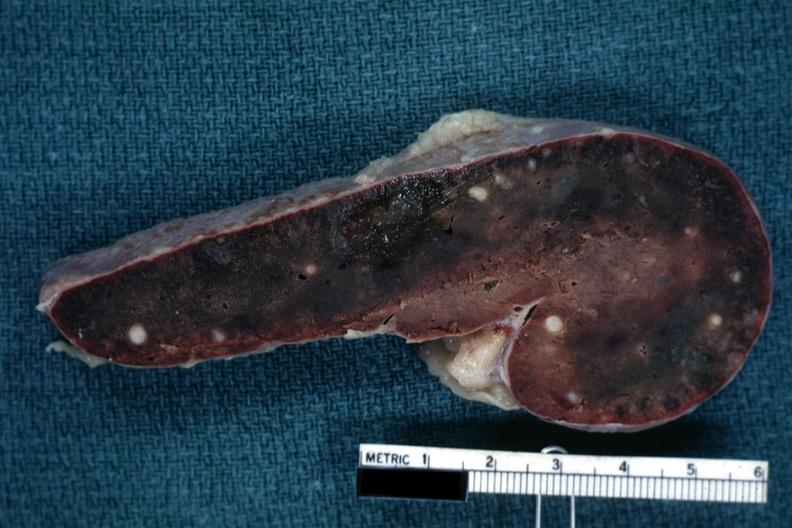how is fixed tissue cut surface parenchyma with obvious granulomas?
Answer the question using a single word or phrase. Congested 